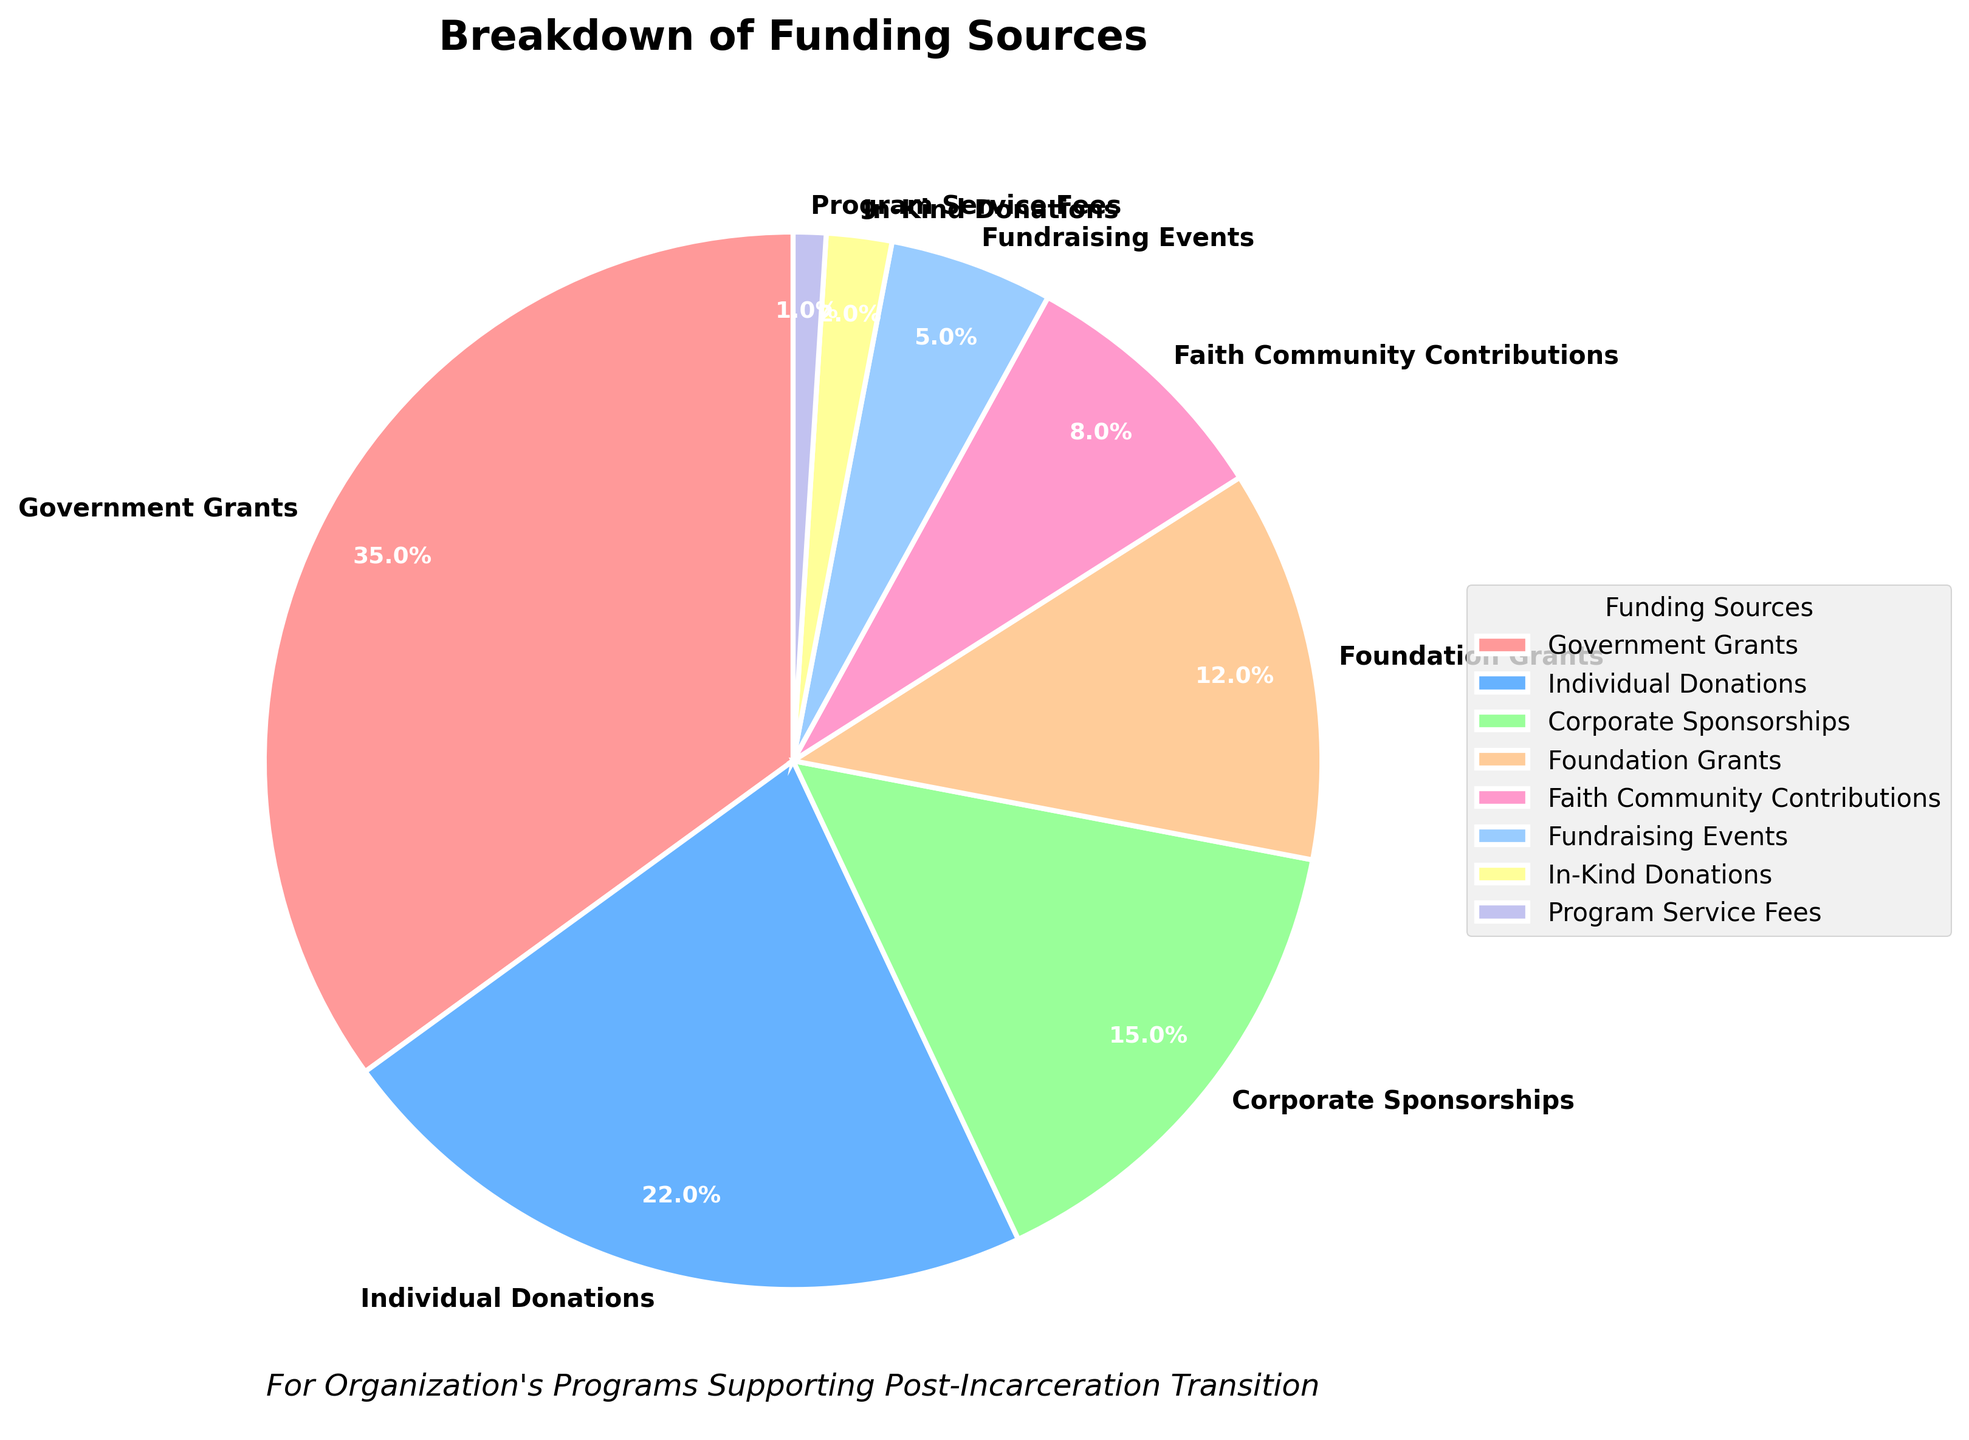What is the largest source of funding for the organization's programs? The largest slice of the pie chart represents the largest source of funding. It is labeled as "Government Grants" with a percentage of 35%
Answer: Government Grants Which funding source contributes the smallest percentage? The smallest slice of the pie chart represents the smallest funding source, labeled as "Program Service Fees" with a percentage of 1%
Answer: Program Service Fees How do individual donations compare to corporate sponsorships in terms of percentage? Individual Donations are represented by a slice labeled with 22%, while Corporate Sponsorships have a slice labeled with 15%. Therefore, Individual Donations contribute more than Corporate Sponsorships
Answer: Individual Donations are higher What is the combined percentage of Foundation Grants and In-Kind Donations? Foundation Grants are 12% and In-Kind Donations are 2%. Adding these together gives 12% + 2% = 14%
Answer: 14% Is the percentage of corporate sponsorships greater than the combined percentage of fundraising events and program service fees? Corporate Sponsorships contribute 15%. Fundraising Events and Program Service Fees contribute 5% and 1% respectively. Their combined percentage is 5% + 1% = 6%, which is less than 15%
Answer: Yes Which funding source has a percentage closest to 10%? The only funding source with a percentage near 10% is "Foundation Grants" with 12%
Answer: Foundation Grants What percentage of funding comes from the faith community contributions? The slice labeled "Faith Community Contributions" represents 8% of the funding
Answer: 8% By how much does the percentage of government grants exceed individual donations? Government Grants are 35%, and Individual Donations are 22%. Subtracting the two gives 35% - 22% = 13%
Answer: 13% What is the total percentage contributed by individual donations, corporate sponsorships, and foundation grants combined? Adding the percentages: Individual Donations (22%) + Corporate Sponsorships (15%) + Foundation Grants (12%) = 22% + 15% + 12% = 49%
Answer: 49% How does the percentage of faith community contributions compare to in-kind donations? Faith Community Contributions are 8%, while In-Kind Donations are 2%, indicating that Faith Community Contributions are higher
Answer: Faith Community Contributions are higher 